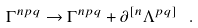Convert formula to latex. <formula><loc_0><loc_0><loc_500><loc_500>\Gamma ^ { n p q } \rightarrow \Gamma ^ { n p q } + \partial ^ { [ n } \Lambda ^ { p q ] } \ .</formula> 